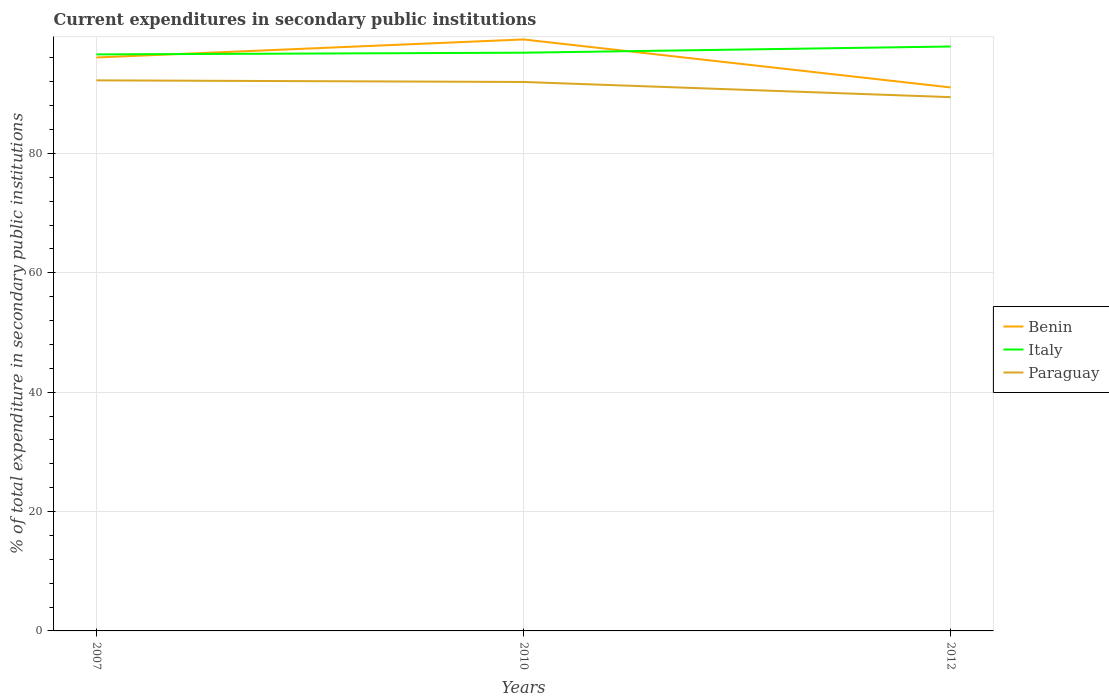How many different coloured lines are there?
Make the answer very short. 3. Across all years, what is the maximum current expenditures in secondary public institutions in Paraguay?
Your answer should be very brief. 89.43. In which year was the current expenditures in secondary public institutions in Benin maximum?
Give a very brief answer. 2012. What is the total current expenditures in secondary public institutions in Italy in the graph?
Offer a terse response. -1.32. What is the difference between the highest and the second highest current expenditures in secondary public institutions in Italy?
Give a very brief answer. 1.32. Is the current expenditures in secondary public institutions in Paraguay strictly greater than the current expenditures in secondary public institutions in Italy over the years?
Make the answer very short. Yes. How many lines are there?
Give a very brief answer. 3. What is the difference between two consecutive major ticks on the Y-axis?
Your answer should be compact. 20. Are the values on the major ticks of Y-axis written in scientific E-notation?
Offer a very short reply. No. Where does the legend appear in the graph?
Provide a succinct answer. Center right. What is the title of the graph?
Provide a succinct answer. Current expenditures in secondary public institutions. What is the label or title of the X-axis?
Make the answer very short. Years. What is the label or title of the Y-axis?
Make the answer very short. % of total expenditure in secondary public institutions. What is the % of total expenditure in secondary public institutions of Benin in 2007?
Ensure brevity in your answer.  96.07. What is the % of total expenditure in secondary public institutions in Italy in 2007?
Provide a succinct answer. 96.59. What is the % of total expenditure in secondary public institutions of Paraguay in 2007?
Keep it short and to the point. 92.24. What is the % of total expenditure in secondary public institutions of Benin in 2010?
Make the answer very short. 99.09. What is the % of total expenditure in secondary public institutions in Italy in 2010?
Make the answer very short. 96.87. What is the % of total expenditure in secondary public institutions in Paraguay in 2010?
Give a very brief answer. 91.97. What is the % of total expenditure in secondary public institutions in Benin in 2012?
Your answer should be compact. 91.05. What is the % of total expenditure in secondary public institutions in Italy in 2012?
Your answer should be compact. 97.91. What is the % of total expenditure in secondary public institutions of Paraguay in 2012?
Your answer should be very brief. 89.43. Across all years, what is the maximum % of total expenditure in secondary public institutions of Benin?
Provide a succinct answer. 99.09. Across all years, what is the maximum % of total expenditure in secondary public institutions of Italy?
Provide a short and direct response. 97.91. Across all years, what is the maximum % of total expenditure in secondary public institutions in Paraguay?
Make the answer very short. 92.24. Across all years, what is the minimum % of total expenditure in secondary public institutions of Benin?
Your response must be concise. 91.05. Across all years, what is the minimum % of total expenditure in secondary public institutions of Italy?
Keep it short and to the point. 96.59. Across all years, what is the minimum % of total expenditure in secondary public institutions in Paraguay?
Keep it short and to the point. 89.43. What is the total % of total expenditure in secondary public institutions in Benin in the graph?
Ensure brevity in your answer.  286.22. What is the total % of total expenditure in secondary public institutions of Italy in the graph?
Provide a short and direct response. 291.37. What is the total % of total expenditure in secondary public institutions of Paraguay in the graph?
Provide a short and direct response. 273.64. What is the difference between the % of total expenditure in secondary public institutions in Benin in 2007 and that in 2010?
Your answer should be very brief. -3.02. What is the difference between the % of total expenditure in secondary public institutions in Italy in 2007 and that in 2010?
Your answer should be very brief. -0.28. What is the difference between the % of total expenditure in secondary public institutions of Paraguay in 2007 and that in 2010?
Offer a terse response. 0.27. What is the difference between the % of total expenditure in secondary public institutions of Benin in 2007 and that in 2012?
Provide a short and direct response. 5.02. What is the difference between the % of total expenditure in secondary public institutions in Italy in 2007 and that in 2012?
Make the answer very short. -1.32. What is the difference between the % of total expenditure in secondary public institutions in Paraguay in 2007 and that in 2012?
Provide a succinct answer. 2.81. What is the difference between the % of total expenditure in secondary public institutions in Benin in 2010 and that in 2012?
Provide a succinct answer. 8.04. What is the difference between the % of total expenditure in secondary public institutions in Italy in 2010 and that in 2012?
Your answer should be very brief. -1.04. What is the difference between the % of total expenditure in secondary public institutions of Paraguay in 2010 and that in 2012?
Ensure brevity in your answer.  2.54. What is the difference between the % of total expenditure in secondary public institutions in Benin in 2007 and the % of total expenditure in secondary public institutions in Italy in 2010?
Provide a succinct answer. -0.8. What is the difference between the % of total expenditure in secondary public institutions of Benin in 2007 and the % of total expenditure in secondary public institutions of Paraguay in 2010?
Provide a succinct answer. 4.1. What is the difference between the % of total expenditure in secondary public institutions in Italy in 2007 and the % of total expenditure in secondary public institutions in Paraguay in 2010?
Your answer should be compact. 4.62. What is the difference between the % of total expenditure in secondary public institutions of Benin in 2007 and the % of total expenditure in secondary public institutions of Italy in 2012?
Ensure brevity in your answer.  -1.84. What is the difference between the % of total expenditure in secondary public institutions of Benin in 2007 and the % of total expenditure in secondary public institutions of Paraguay in 2012?
Give a very brief answer. 6.64. What is the difference between the % of total expenditure in secondary public institutions in Italy in 2007 and the % of total expenditure in secondary public institutions in Paraguay in 2012?
Give a very brief answer. 7.16. What is the difference between the % of total expenditure in secondary public institutions of Benin in 2010 and the % of total expenditure in secondary public institutions of Italy in 2012?
Your answer should be very brief. 1.18. What is the difference between the % of total expenditure in secondary public institutions in Benin in 2010 and the % of total expenditure in secondary public institutions in Paraguay in 2012?
Keep it short and to the point. 9.66. What is the difference between the % of total expenditure in secondary public institutions of Italy in 2010 and the % of total expenditure in secondary public institutions of Paraguay in 2012?
Provide a succinct answer. 7.45. What is the average % of total expenditure in secondary public institutions in Benin per year?
Give a very brief answer. 95.41. What is the average % of total expenditure in secondary public institutions of Italy per year?
Ensure brevity in your answer.  97.12. What is the average % of total expenditure in secondary public institutions in Paraguay per year?
Provide a succinct answer. 91.21. In the year 2007, what is the difference between the % of total expenditure in secondary public institutions in Benin and % of total expenditure in secondary public institutions in Italy?
Offer a very short reply. -0.52. In the year 2007, what is the difference between the % of total expenditure in secondary public institutions of Benin and % of total expenditure in secondary public institutions of Paraguay?
Keep it short and to the point. 3.83. In the year 2007, what is the difference between the % of total expenditure in secondary public institutions of Italy and % of total expenditure in secondary public institutions of Paraguay?
Your response must be concise. 4.35. In the year 2010, what is the difference between the % of total expenditure in secondary public institutions in Benin and % of total expenditure in secondary public institutions in Italy?
Your answer should be compact. 2.22. In the year 2010, what is the difference between the % of total expenditure in secondary public institutions in Benin and % of total expenditure in secondary public institutions in Paraguay?
Offer a terse response. 7.12. In the year 2010, what is the difference between the % of total expenditure in secondary public institutions in Italy and % of total expenditure in secondary public institutions in Paraguay?
Offer a very short reply. 4.9. In the year 2012, what is the difference between the % of total expenditure in secondary public institutions in Benin and % of total expenditure in secondary public institutions in Italy?
Make the answer very short. -6.86. In the year 2012, what is the difference between the % of total expenditure in secondary public institutions of Benin and % of total expenditure in secondary public institutions of Paraguay?
Keep it short and to the point. 1.62. In the year 2012, what is the difference between the % of total expenditure in secondary public institutions of Italy and % of total expenditure in secondary public institutions of Paraguay?
Offer a very short reply. 8.48. What is the ratio of the % of total expenditure in secondary public institutions in Benin in 2007 to that in 2010?
Make the answer very short. 0.97. What is the ratio of the % of total expenditure in secondary public institutions in Italy in 2007 to that in 2010?
Your answer should be very brief. 1. What is the ratio of the % of total expenditure in secondary public institutions in Benin in 2007 to that in 2012?
Offer a very short reply. 1.06. What is the ratio of the % of total expenditure in secondary public institutions in Italy in 2007 to that in 2012?
Provide a succinct answer. 0.99. What is the ratio of the % of total expenditure in secondary public institutions of Paraguay in 2007 to that in 2012?
Offer a terse response. 1.03. What is the ratio of the % of total expenditure in secondary public institutions of Benin in 2010 to that in 2012?
Offer a very short reply. 1.09. What is the ratio of the % of total expenditure in secondary public institutions in Italy in 2010 to that in 2012?
Give a very brief answer. 0.99. What is the ratio of the % of total expenditure in secondary public institutions in Paraguay in 2010 to that in 2012?
Provide a succinct answer. 1.03. What is the difference between the highest and the second highest % of total expenditure in secondary public institutions of Benin?
Make the answer very short. 3.02. What is the difference between the highest and the second highest % of total expenditure in secondary public institutions of Italy?
Your answer should be very brief. 1.04. What is the difference between the highest and the second highest % of total expenditure in secondary public institutions in Paraguay?
Your answer should be compact. 0.27. What is the difference between the highest and the lowest % of total expenditure in secondary public institutions of Benin?
Provide a succinct answer. 8.04. What is the difference between the highest and the lowest % of total expenditure in secondary public institutions of Italy?
Your answer should be very brief. 1.32. What is the difference between the highest and the lowest % of total expenditure in secondary public institutions of Paraguay?
Keep it short and to the point. 2.81. 